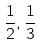<formula> <loc_0><loc_0><loc_500><loc_500>\frac { 1 } { 2 } , \frac { 1 } { 3 }</formula> 